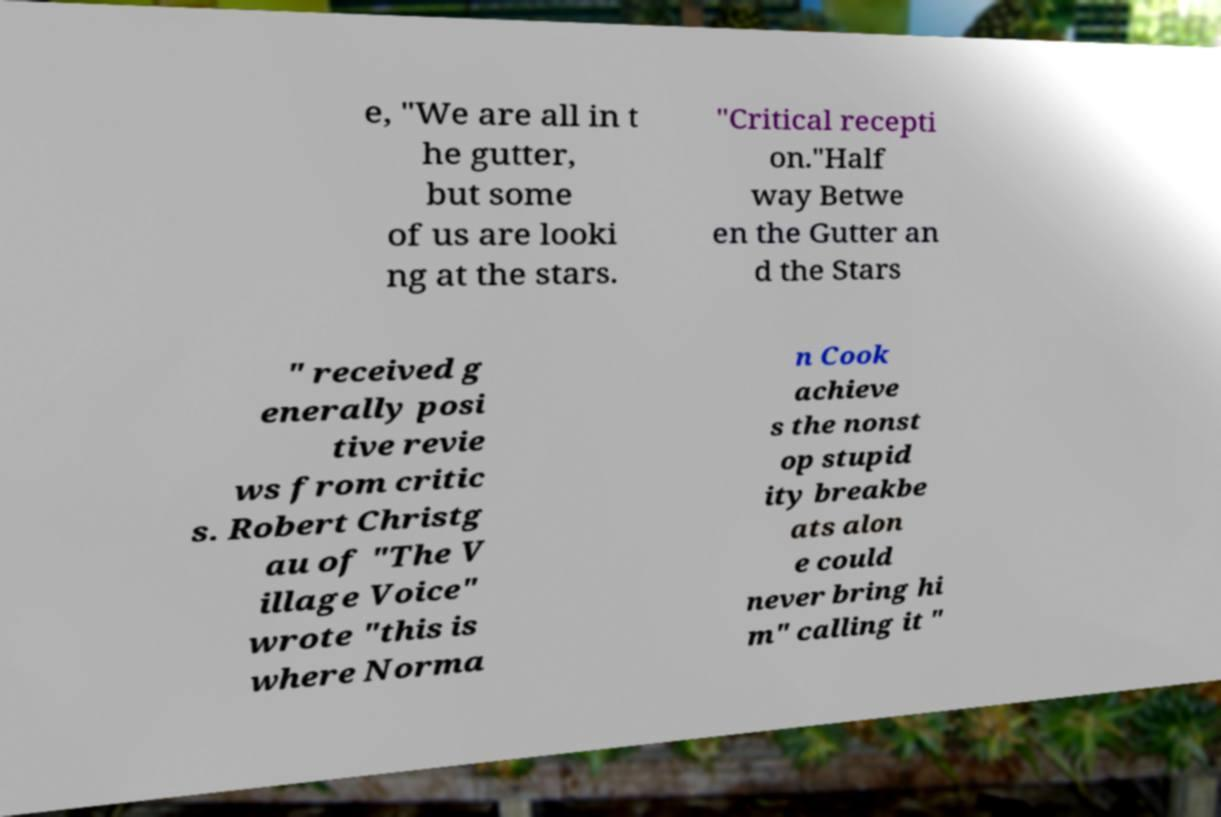Could you extract and type out the text from this image? e, "We are all in t he gutter, but some of us are looki ng at the stars. "Critical recepti on."Half way Betwe en the Gutter an d the Stars " received g enerally posi tive revie ws from critic s. Robert Christg au of "The V illage Voice" wrote "this is where Norma n Cook achieve s the nonst op stupid ity breakbe ats alon e could never bring hi m" calling it " 